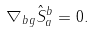Convert formula to latex. <formula><loc_0><loc_0><loc_500><loc_500>\nabla _ { b } { _ { g } { \hat { S } } _ { a } ^ { b } } = 0 .</formula> 